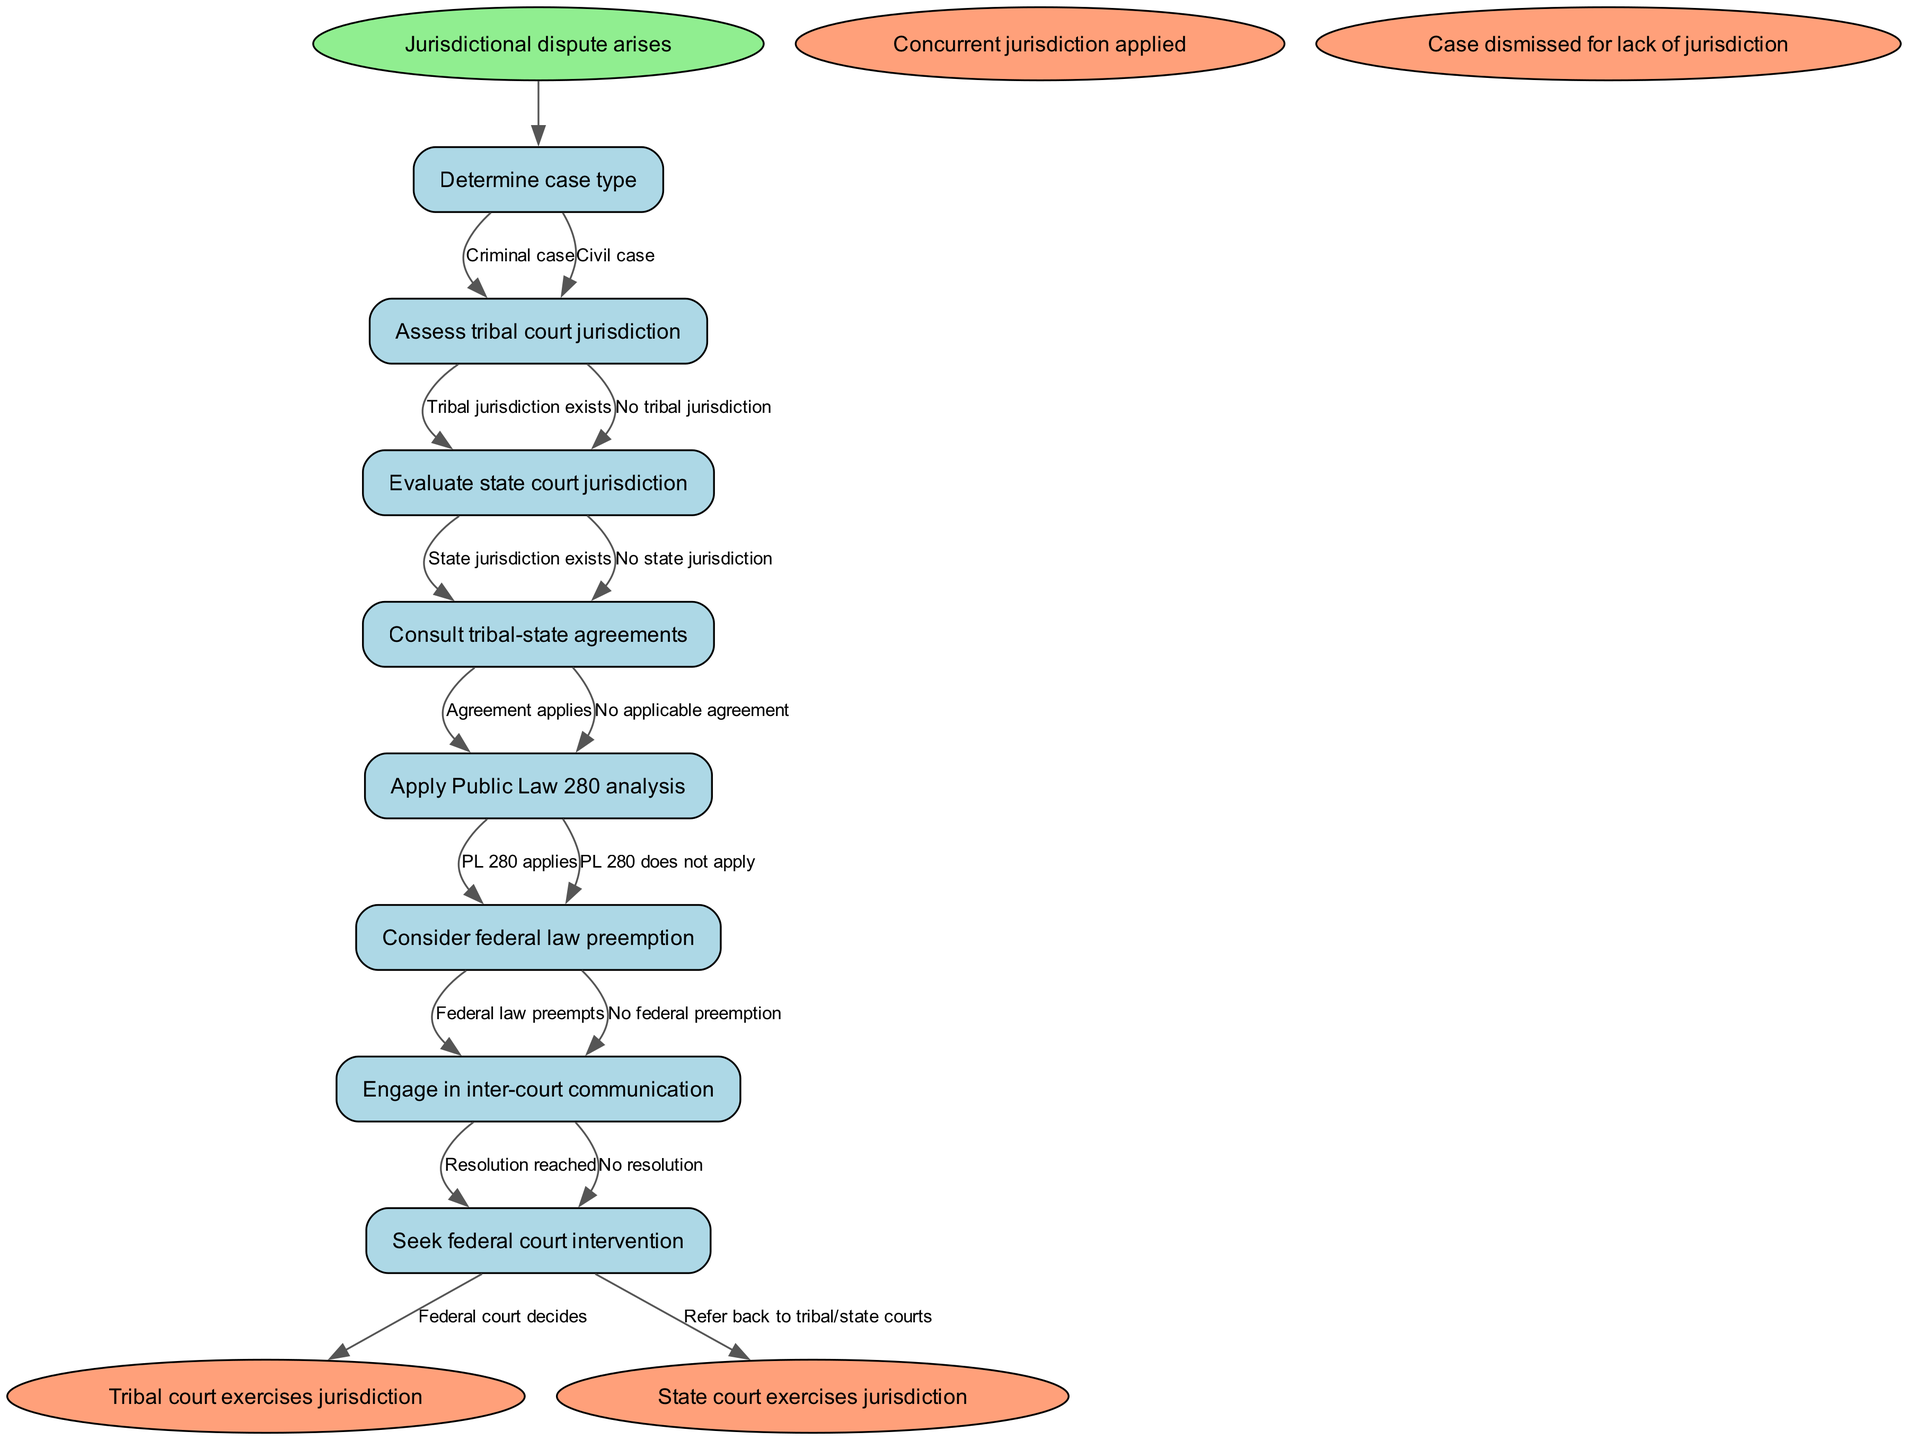What is the first step after a jurisdictional dispute arises? The diagram indicates that the first step is to "Determine case type." This is the next node connected to the start node of the flow chart.
Answer: Determine case type How many types of case are identified in the flowchart? In the flowchart, there are two types of case identified: "Criminal case" and "Civil case." These are the edges stemming from the "Determine case type" node.
Answer: Two What happens if "Tribal jurisdiction exists"? If "Tribal jurisdiction exists," the flowchart shows that the next step would be to "Evaluate state court jurisdiction," which is the next node in the sequence.
Answer: Evaluate state court jurisdiction What are the two potential outcomes from the "Engage in inter-court communication"? From "Engage in inter-court communication," the diagram provides two possible outcomes: "Resolution reached" and "No resolution." These are the edges stemming from this node.
Answer: Resolution reached, No resolution If there is "No applicable agreement," what is the next step? If there is "No applicable agreement," the following step in the flowchart is to "Apply Public Law 280 analysis," as indicated by the flow of nodes following that decision.
Answer: Apply Public Law 280 analysis What does "Seek federal court intervention" lead to if the court decides? If the federal court intervenes and decides, the next step indicated in the flowchart is "Federal court decides," which is one of the outcomes leading from the "Seek federal court intervention" node.
Answer: Federal court decides Under what circumstance would a case be dismissed due to lack of jurisdiction? A case would be dismissed for lack of jurisdiction when there are no valid claims to either "Tribal jurisdiction" or "State jurisdiction," leading to an end state that indicates the case cannot proceed.
Answer: Case dismissed for lack of jurisdiction What is the relationship between "Consider federal law preemption" and "Engage in inter-court communication"? "Consider federal law preemption" is a step that can lead to either federal law preempting or not preempting jurisdiction, regardless of the outcome, inter-court communication must occur afterward to seek resolution, following the established flow of the diagram.
Answer: Intermediary step How many end nodes signify outcomes of the jurisdictional dispute resolution protocol? The diagram identifies four end nodes that signify outcomes: "Tribal court exercises jurisdiction," "State court exercises jurisdiction," "Concurrent jurisdiction applied," and "Case dismissed for lack of jurisdiction." This is derived from the terminal points of the flowchart.
Answer: Four 